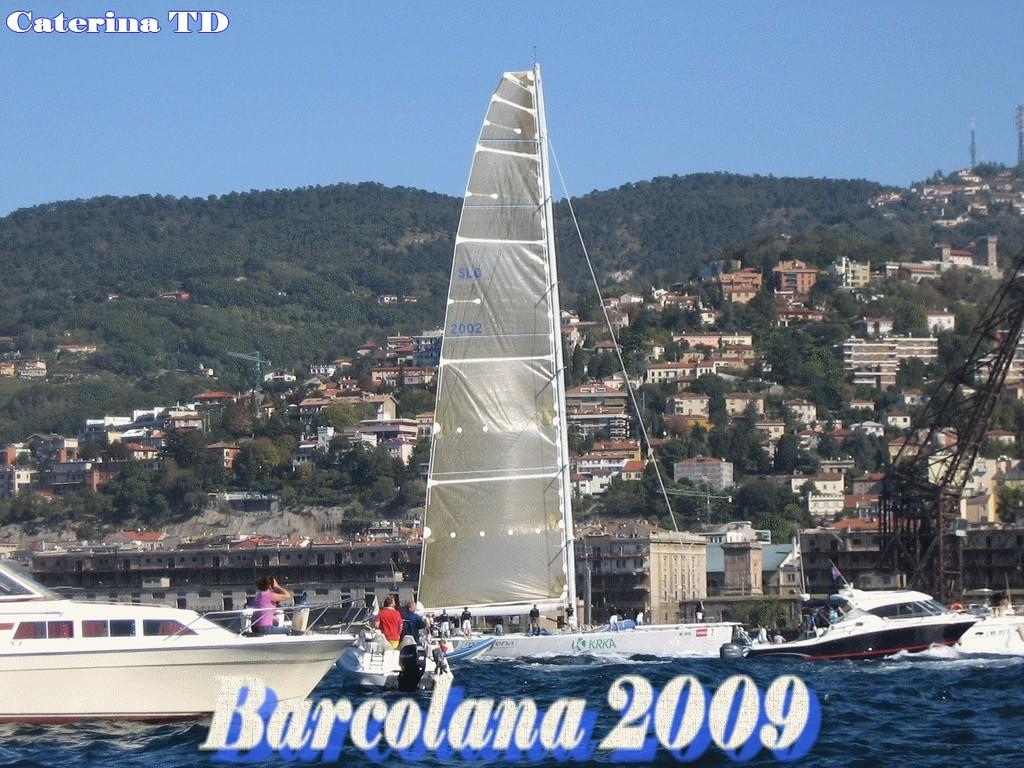What is the main subject of the image? The main subject of the image is a boat. Where is the boat located? The boat is on the water. Are there any people in the boat? Yes, there are people in the boat. What can be seen in the background of the image? In the background of the image, there are buildings, trees, mountains, and the sky. What type of force is being applied to the boat in the image? There is no indication of any force being applied to the boat in the image. Can you see a tent in the background of the image? No, there is no tent present in the image. 